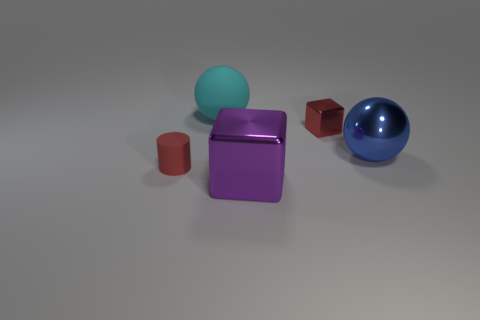Add 5 small red things. How many objects exist? 10 Subtract all cubes. How many objects are left? 3 Subtract all rubber things. Subtract all large spheres. How many objects are left? 1 Add 2 rubber cylinders. How many rubber cylinders are left? 3 Add 4 blue spheres. How many blue spheres exist? 5 Subtract 0 yellow balls. How many objects are left? 5 